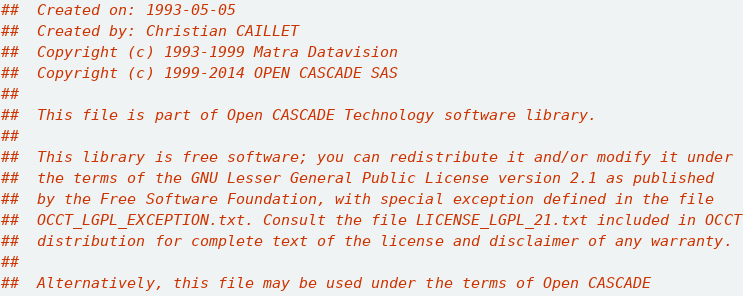Convert code to text. <code><loc_0><loc_0><loc_500><loc_500><_Nim_>##  Created on: 1993-05-05
##  Created by: Christian CAILLET
##  Copyright (c) 1993-1999 Matra Datavision
##  Copyright (c) 1999-2014 OPEN CASCADE SAS
##
##  This file is part of Open CASCADE Technology software library.
##
##  This library is free software; you can redistribute it and/or modify it under
##  the terms of the GNU Lesser General Public License version 2.1 as published
##  by the Free Software Foundation, with special exception defined in the file
##  OCCT_LGPL_EXCEPTION.txt. Consult the file LICENSE_LGPL_21.txt included in OCCT
##  distribution for complete text of the license and disclaimer of any warranty.
##
##  Alternatively, this file may be used under the terms of Open CASCADE</code> 